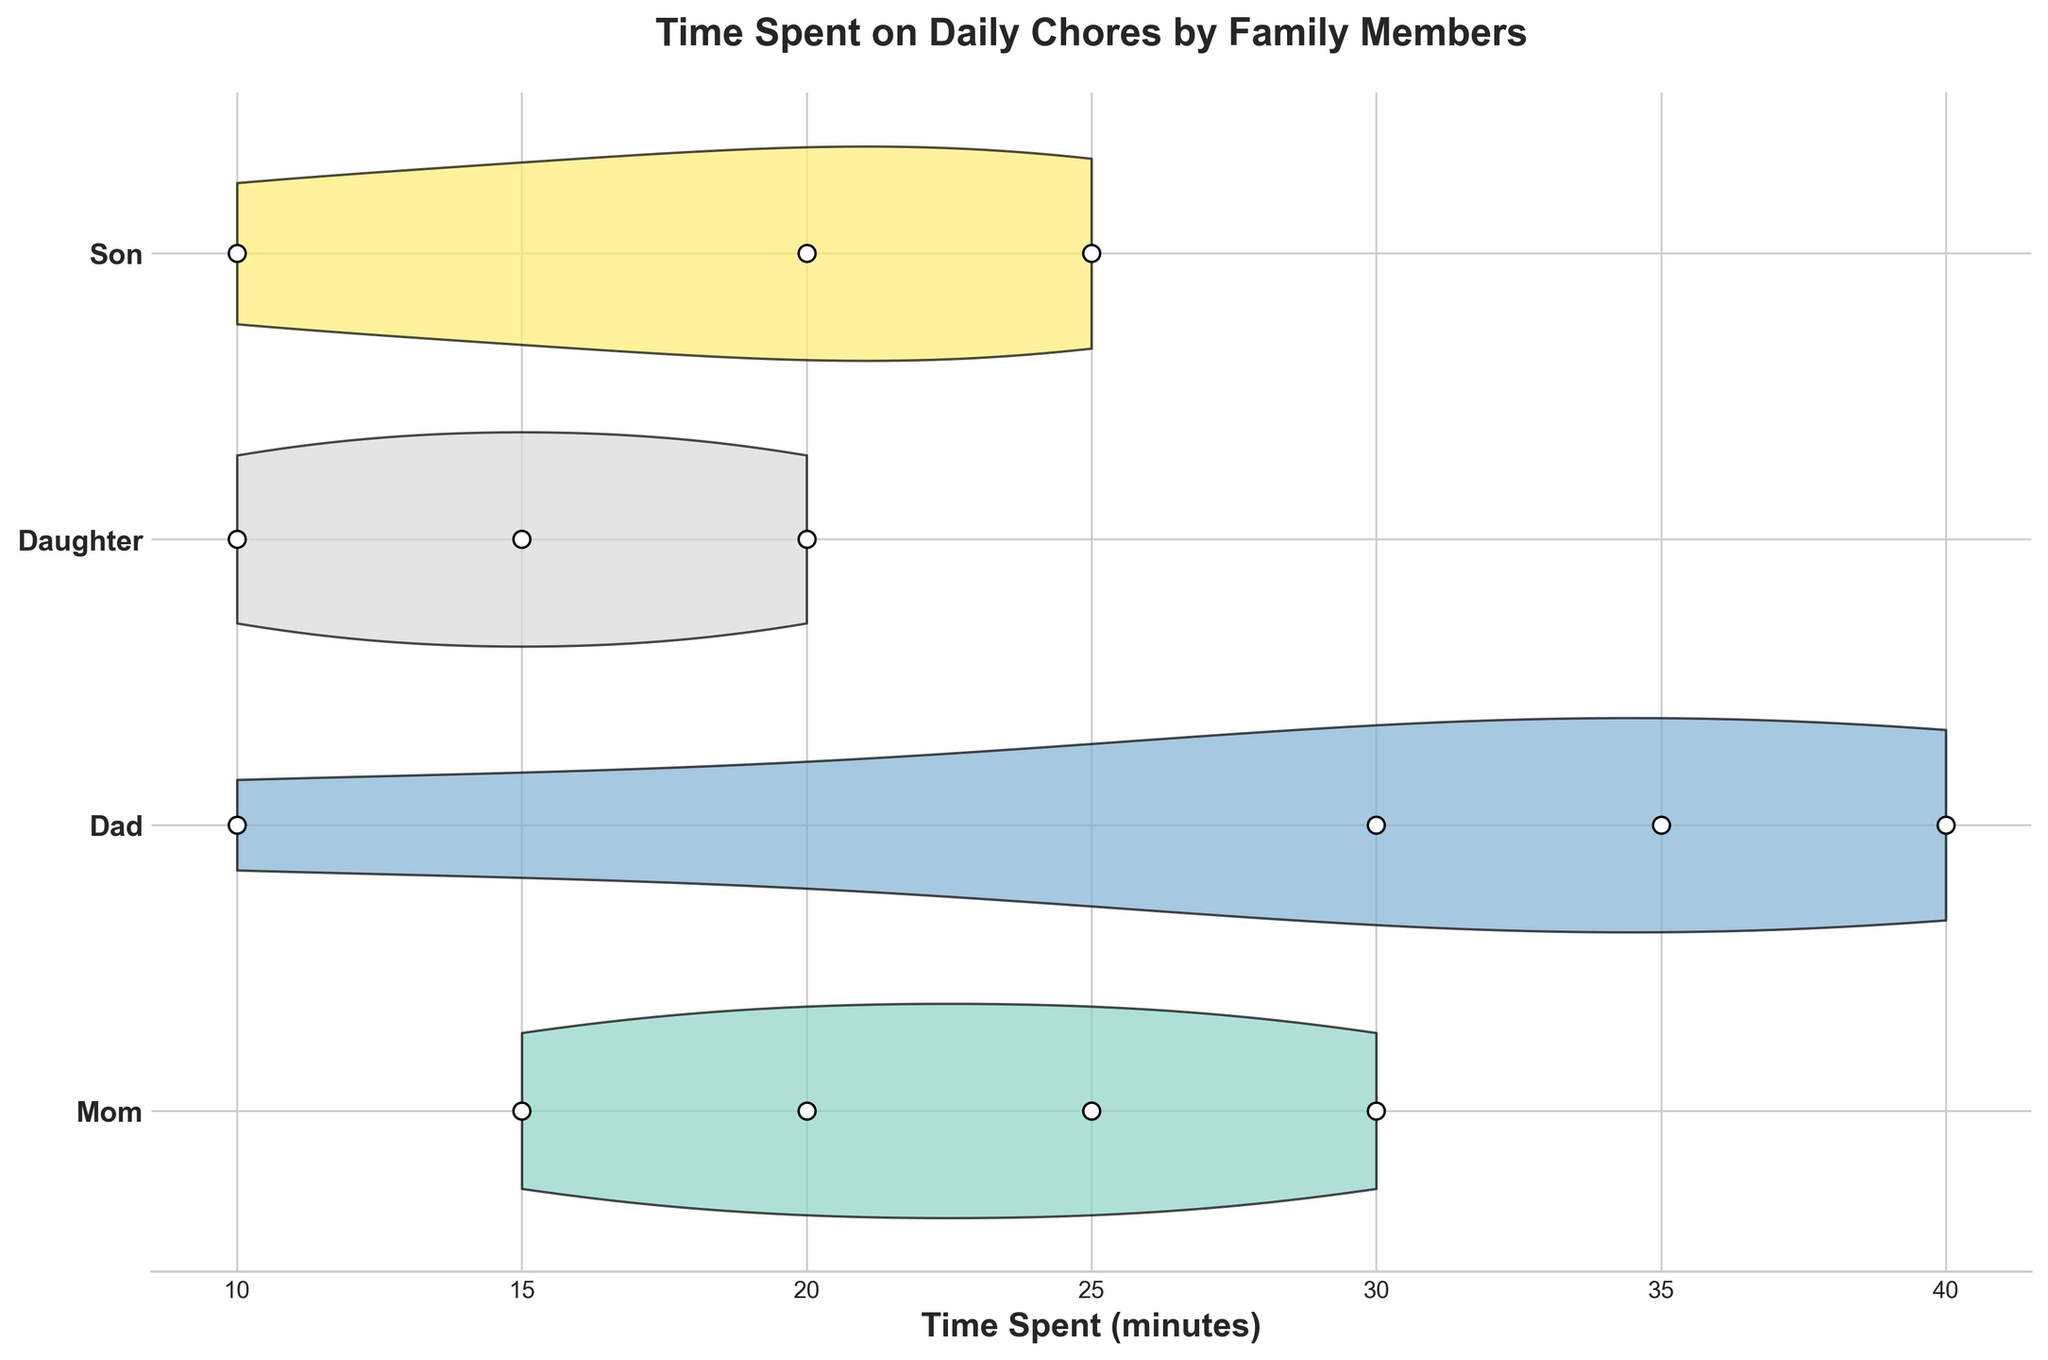What's the title of the chart? The title of the chart is usually located at the top of the figure and provides a summary of what the chart will display. In this case, it is labeled "Time Spent on Daily Chores by Family Members".
Answer: Time Spent on Daily Chores by Family Members How many family members are shown on the chart? The y-axis displays different family members, each indicated by a unique position. From the chart, we can see that there are four family members labeled: Mom, Dad, Daughter, and Son.
Answer: 4 Which family member spends the most time on a single chore, and what is that chore? By examining the violin plots, we note the length of each plot represents the time spent on chores. Dad appears to have the longest violin plot for Gardening, indicating the most time spent.
Answer: Dad, Gardening Who spends the least amount of time on Trash Disposal and how much time do they spend? The box plots at the corresponding y-axis position show the time spent on different chores. Dad's violin plot for Trash Disposal is the shortest, indicating the least amount of time spent, which is 10 minutes.
Answer: Dad, 10 minutes How does the time spent by Mom on Washing Dishes compare with the time spent by Daughter on Helping with Dishes? To compare, look at the position of time spent by both family members for the corresponding chores. Mom spends 25 minutes on Washing Dishes, while Daughter spends 10 minutes on Helping with Dishes.
Answer: Mom spends more time What's the average time spent on chores by the Daughter? To calculate the average time, add the time spent on Tidying Up Toys (20), Watering Plants (15), and Helping with Dishes (10), then divide by the number of activities (3). (20 + 15 + 10) / 3 = 15 minutes.
Answer: 15 minutes Which family member has the most diversity in the time spent on their chores? Examining the widths of the violin plots, the member with the widest spread of time spent is Dad, as indicated by the varied range of times for Gardening, Trash Disposal, Car Washing, and Repair Work.
Answer: Dad Who spends more time on dishes, and how much more? By comparing the times, Mom spends 25 minutes Washing Dishes while Daughter spends 10 minutes Helping with Dishes. The difference is 25 - 10 = 15 minutes.
Answer: Mom spends 15 minutes more Which family member has the least variance in time spent on their chores? Variance can be seen through the consistency in the length of the violin plots. Daughter’s violin plots (Tidying Up Toys, Watering Plants, Helping with Dishes) are most similar, indicating the least variance in time spent.
Answer: Daughter 